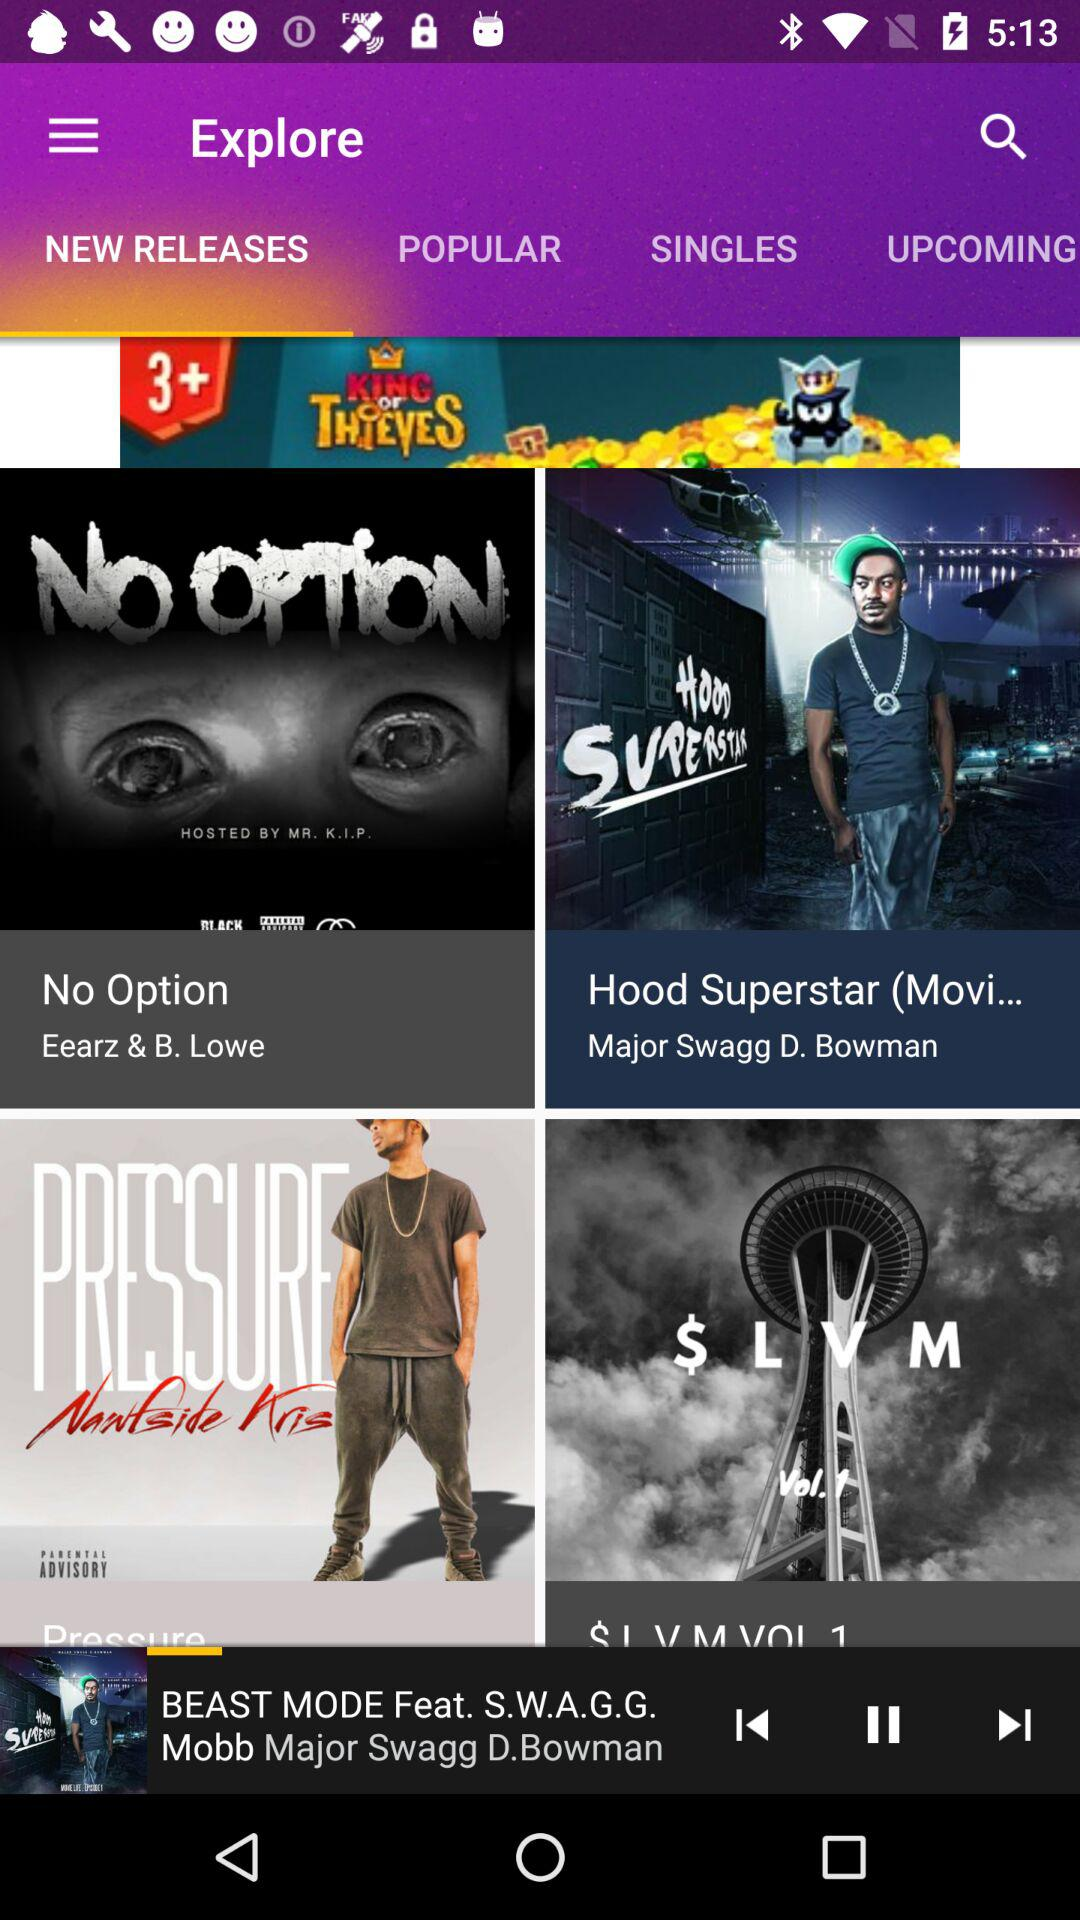Who is the singer of "No Option"? The singers are Eearz and B. Lowe. 